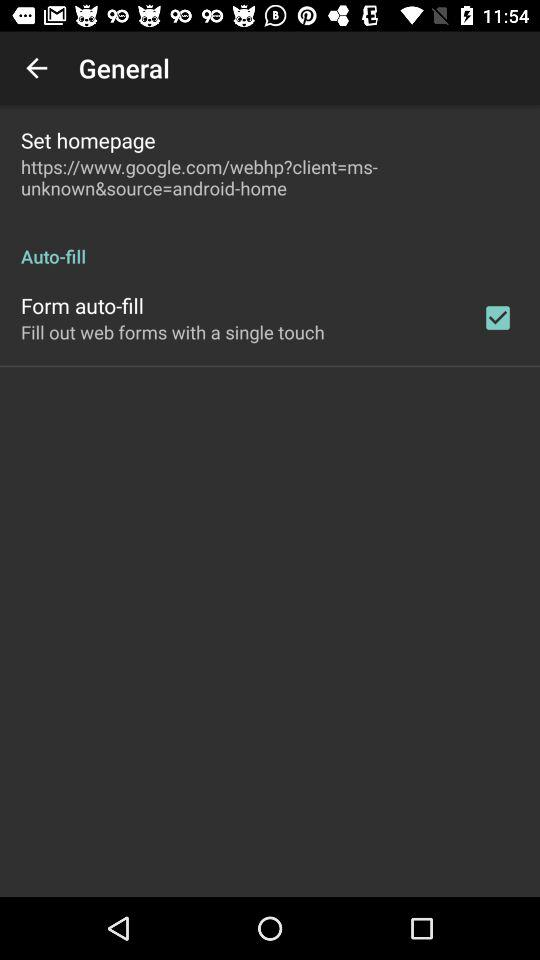Which option is marked as checked? The checked option is "Form auto-fill". 